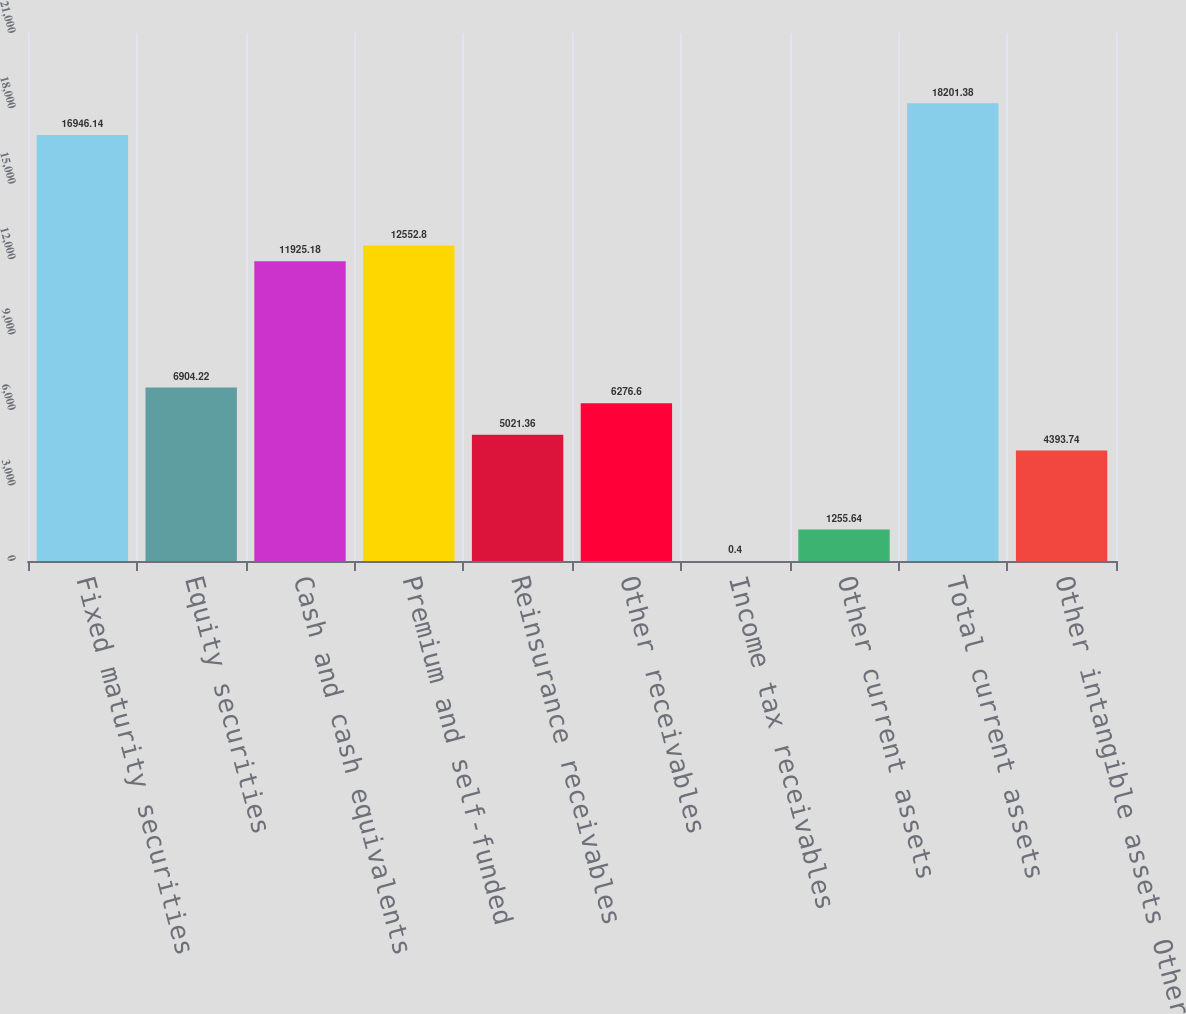Convert chart. <chart><loc_0><loc_0><loc_500><loc_500><bar_chart><fcel>Fixed maturity securities<fcel>Equity securities<fcel>Cash and cash equivalents<fcel>Premium and self-funded<fcel>Reinsurance receivables<fcel>Other receivables<fcel>Income tax receivables<fcel>Other current assets<fcel>Total current assets<fcel>Other intangible assets Other<nl><fcel>16946.1<fcel>6904.22<fcel>11925.2<fcel>12552.8<fcel>5021.36<fcel>6276.6<fcel>0.4<fcel>1255.64<fcel>18201.4<fcel>4393.74<nl></chart> 